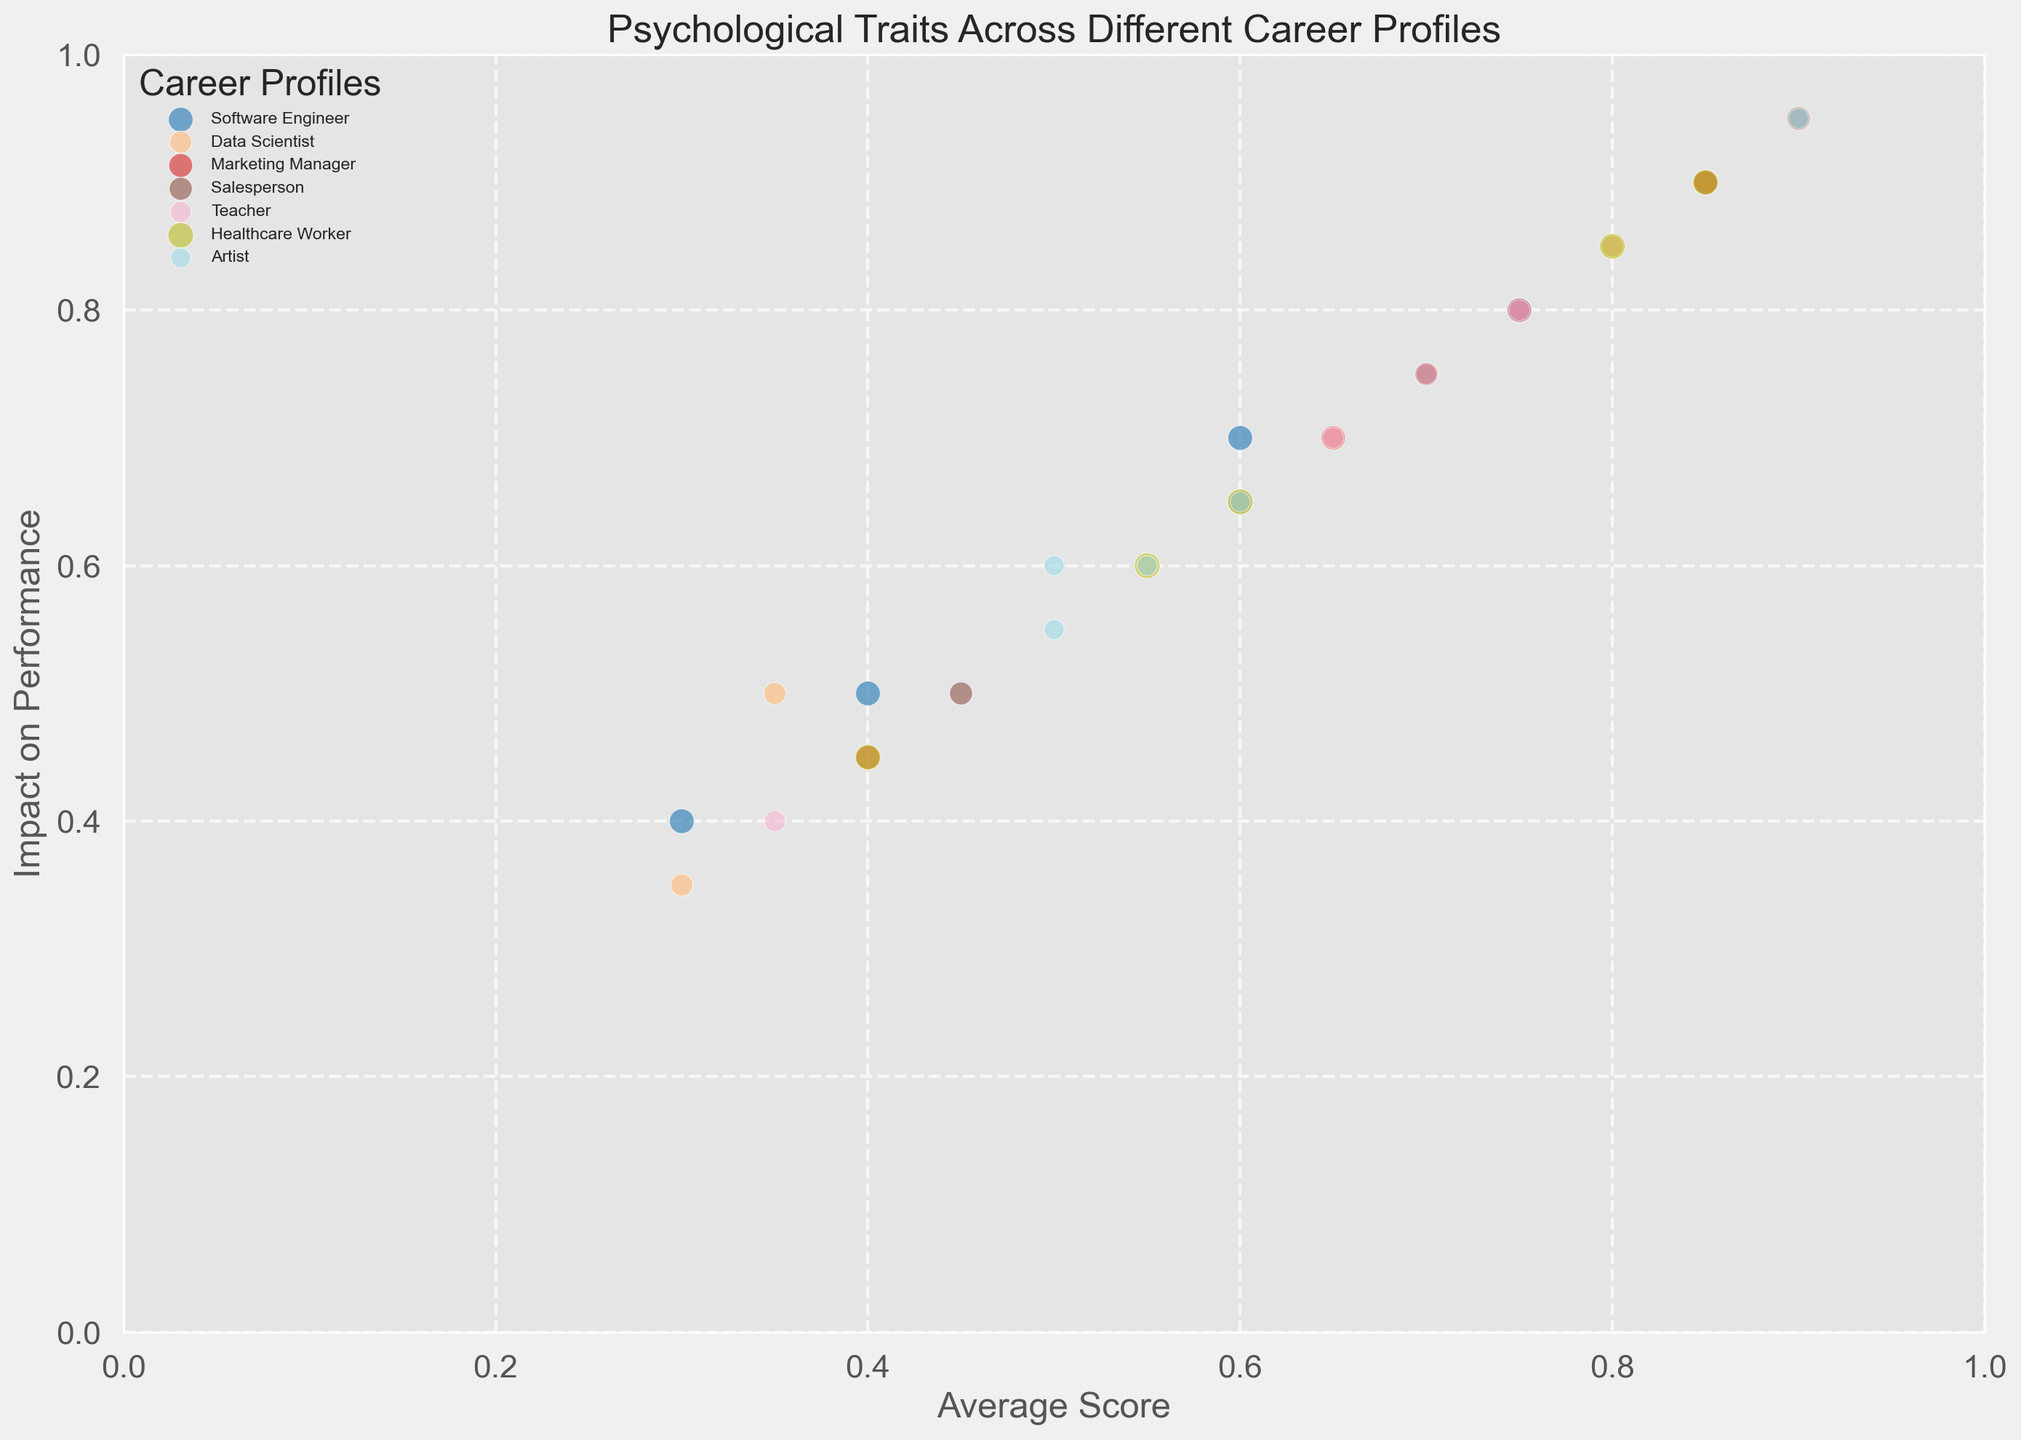What career profile has the highest impact on performance value for Extraversion? To find the answer, look for the bubble with the "Extraversion" trait and the highest position on the y-axis (Impact on Performance). The highest point is 0.95, associated with the Salesperson profile.
Answer: Salesperson Which trait has the lowest average score in the Data Scientist profile? Identify the bubbles labeled "Data Scientist" and compare the average scores along the x-axis. The lowest average score for Data Scientist is 0.3, associated with the Neuroticism trait.
Answer: Neuroticism Compare the impact of Openness on job performance between Software Engineers and Artists. Which is higher? Look at the Openness trait bubbles for both Software Engineers and Artists. Compare their vertical positions on the y-axis. Artist has a higher impact on performance (0.95) compared to Software Engineer (0.8).
Answer: Artist What is the average of the impact on performance for Neuroticism across all career profiles? Sum the impact on performance values for Neuroticism across all profiles and divide by the number of profiles. Calculation: (0.4 + 0.35 + 0.45 + 0.5 + 0.4 + 0.55) / 6 = 0.44.
Answer: 0.44 Which career profile has the largest bubble size, and what does it represent? Identify the biggest bubble visually. The largest bubble is associated with Healthcare Worker, representing a size of 160.
Answer: Healthcare Worker How do the average scores for Conscientiousness compare between Teachers and Marketing Managers? Compare the positions of the bubbles labeled "Conscientiousness" along the x-axis for Teachers (0.8) and Marketing Managers (0.75). Teachers have a higher average score.
Answer: Teachers For the Agreeableness trait, which career profile shows the highest impact on performance? Look at the y-axis positions of the "Agreeableness" bubbles. Healthcare Worker, with an impact score of 0.85, is the highest.
Answer: Healthcare Worker Calculate the difference in average scores for Openness between Healthcare Workers and Salespersons. Subtract the average score of Salespersons (0.6) from Healthcare Workers (0.6), resulting in 0.65 - 0.6 = 0.05.
Answer: 0.05 What is the color associated with the Artist career profile bubbles? Identify the bubble labeled "Artist." The color associated with the bubbles for Artists is blue.
Answer: Blue 